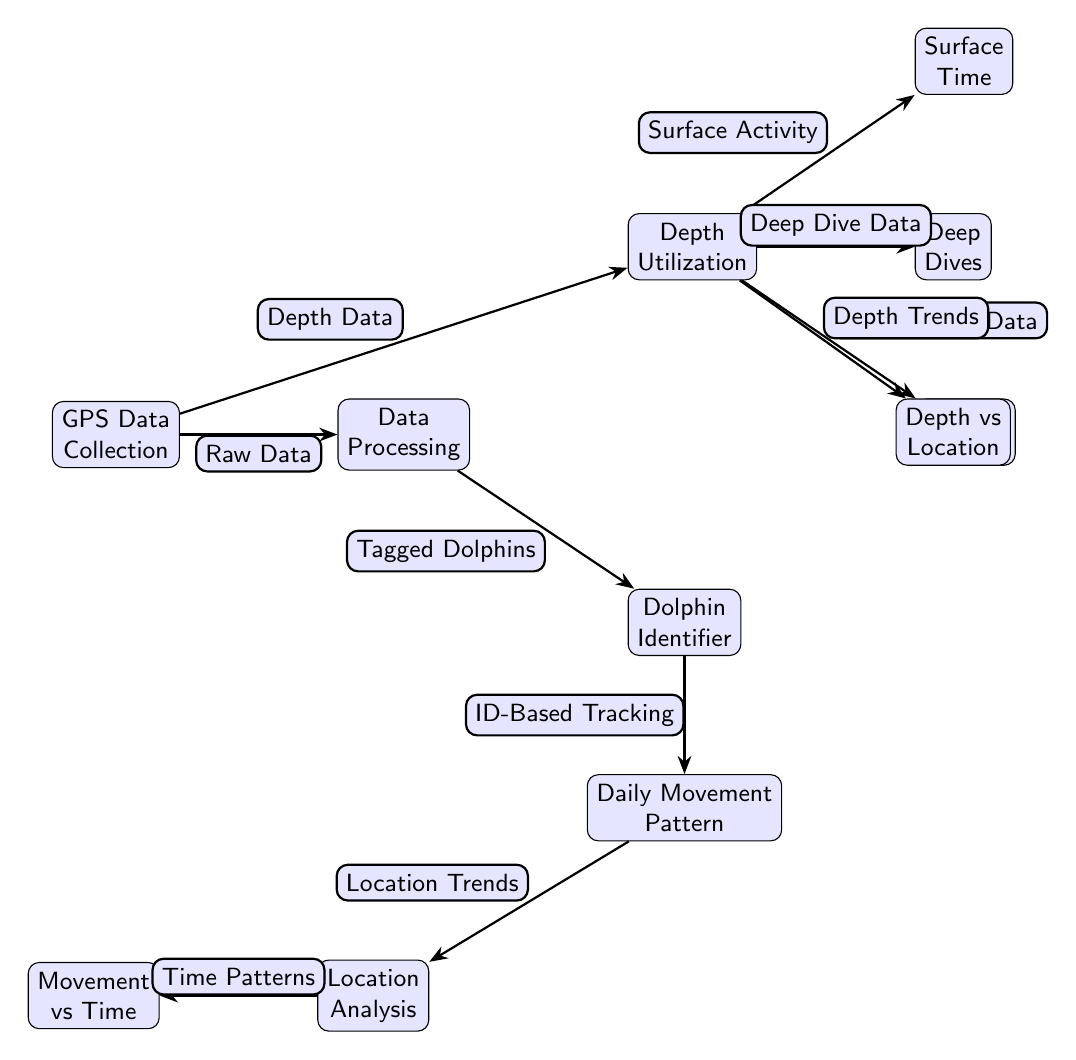What is the first step in the process according to the diagram? The diagram begins with "GPS Data Collection," which is the first node and represents the starting point of the process.
Answer: GPS Data Collection How many main nodes are there in the diagram? By counting all labeled nodes in the diagram, we find there are a total of 8 main nodes that represent different stages of the analysis.
Answer: 8 What type of data is labeled as flowing from "GPS Data Collection" to "Data Processing"? The edge labeled "Raw Data" indicates that the initial data collected from GPS tracking is processed, suggesting unrefined information before further analysis.
Answer: Raw Data Which node comes after "Data Processing" and indicates dolphin identification? After "Data Processing," the next node is "Dolphin Identifier," which signifies the step where individual dolphins are identified for tracking purposes.
Answer: Dolphin Identifier What does the "Depth Utilization" node connect to directly? The "Depth Utilization" node is directly connected to several nodes, specifically "Surface Time," "Deep Dives," "Shallow Dives," and "Depth vs Location," representing different aspects of depth data analysis.
Answer: Surface Time, Deep Dives, Shallow Dives, Depth vs Location What is indicated by the label "ID-Based Tracking" in relation to the previous node? The label "ID-Based Tracking" indicates a process that occurs after dolphin identification, implying that tracking is conducted based on the unique identifiers of the dolphins.
Answer: ID-Based Tracking Which node shares connections with both "Daily Movement Pattern" and "Depth Utilization"? The node "Location Analysis" connects to both "Daily Movement Pattern" and "Depth Utilization," highlighting its role in analyzing how movement correlates with location and depth in the environment.
Answer: Location Analysis What aspect of the dolphins' behavior does "Surface Activity" refer to? The term "Surface Activity" refers to the time spent at or near the surface of the water by the dolphins, suggesting an area of focus within the depth data.
Answer: Surface Activity How does "Movement vs Time" relate to the overarching flow of the diagram? "Movement vs Time" is linked to "Location Analysis," indicating that it examines temporal patterns in dolphin movements in relation to their locations over time, a crucial aspect of the movement data.
Answer: Movement vs Time 